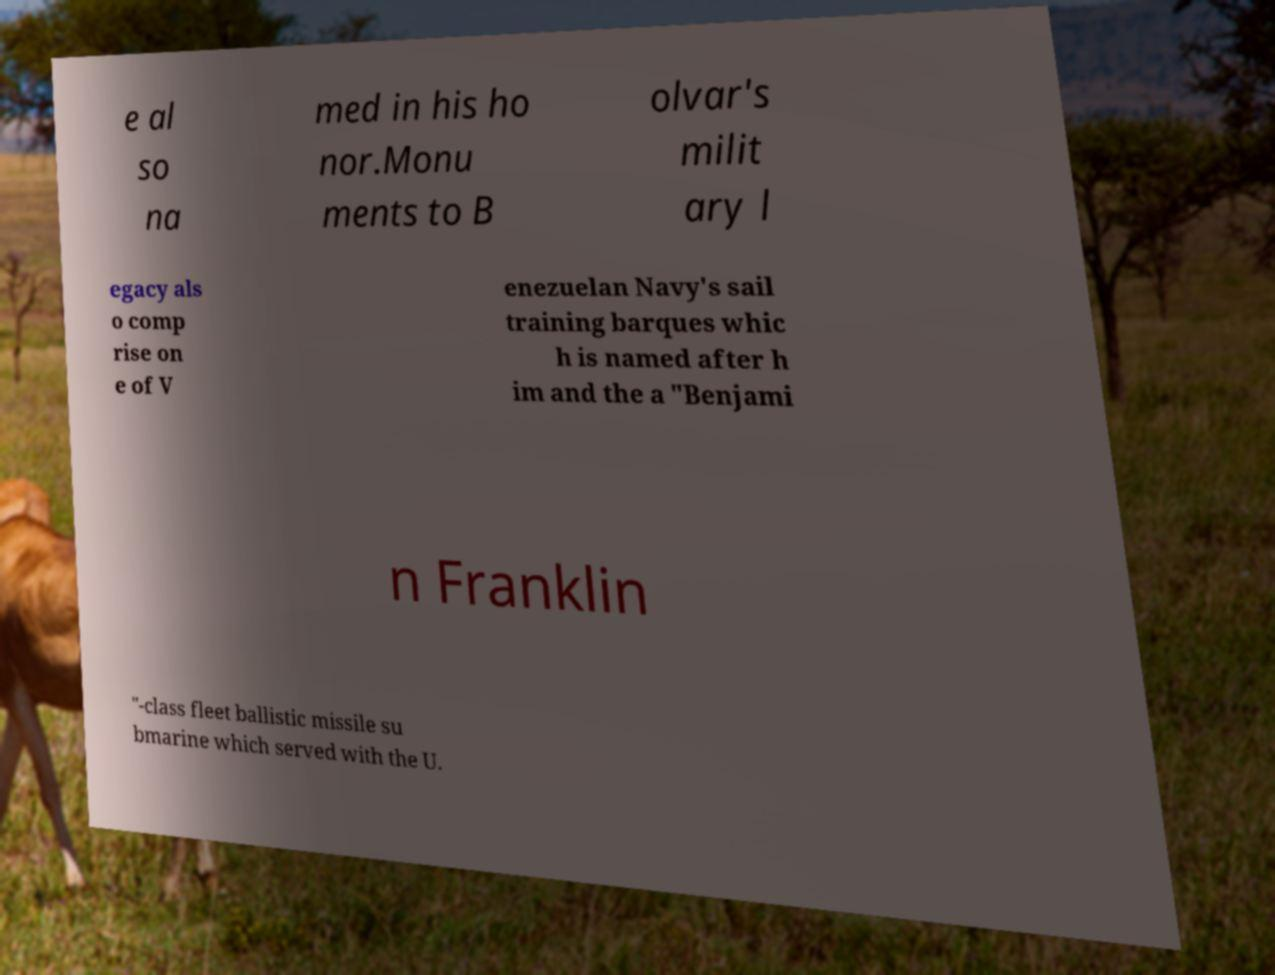Could you extract and type out the text from this image? e al so na med in his ho nor.Monu ments to B olvar's milit ary l egacy als o comp rise on e of V enezuelan Navy's sail training barques whic h is named after h im and the a "Benjami n Franklin "-class fleet ballistic missile su bmarine which served with the U. 